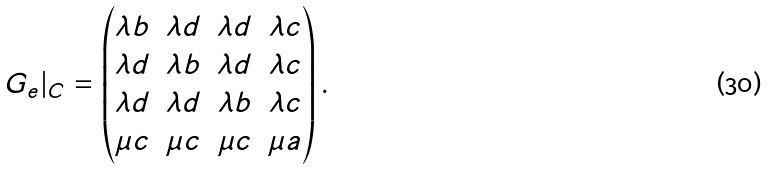Convert formula to latex. <formula><loc_0><loc_0><loc_500><loc_500>G _ { e } | _ { C } = \begin{pmatrix} \lambda b & \lambda d & \lambda d & \lambda c \\ \lambda d & \lambda b & \lambda d & \lambda c \\ \lambda d & \lambda d & \lambda b & \lambda c \\ \mu c & \mu c & \mu c & \mu a \end{pmatrix} .</formula> 